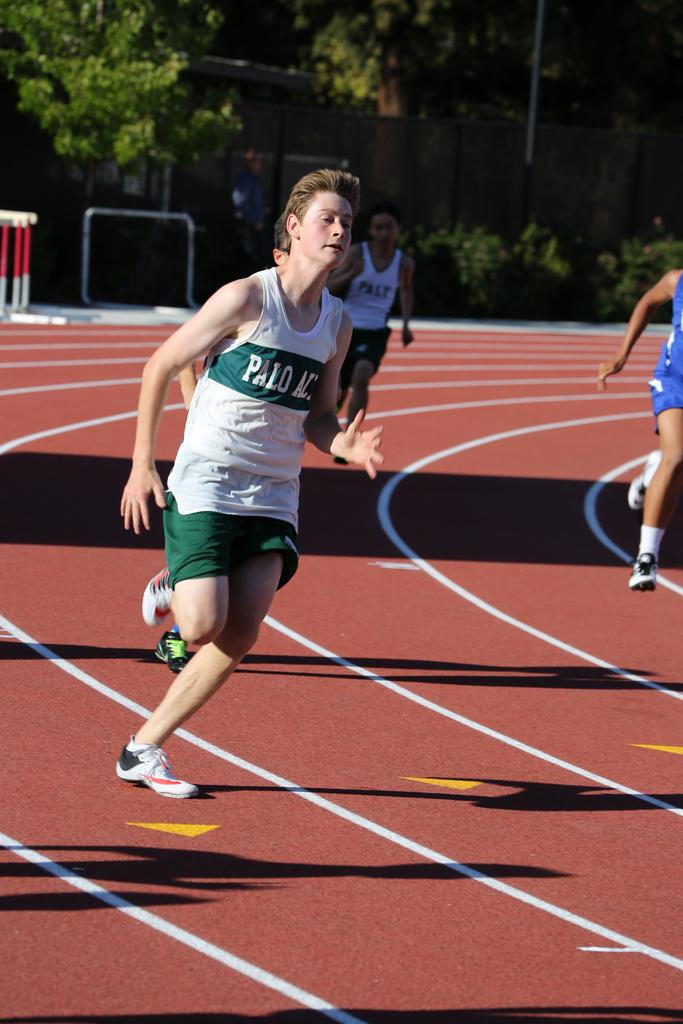Who is present in the image? There are people in the image. What are the people doing in the image? The people are running. What type of natural environment can be seen in the image? There are trees visible in the image. What structures are present in the image? There are poles in the image. What type of bread can be seen in the hands of the people running in the image? There is no bread present in the image; the people are running without any visible objects in their hands. 